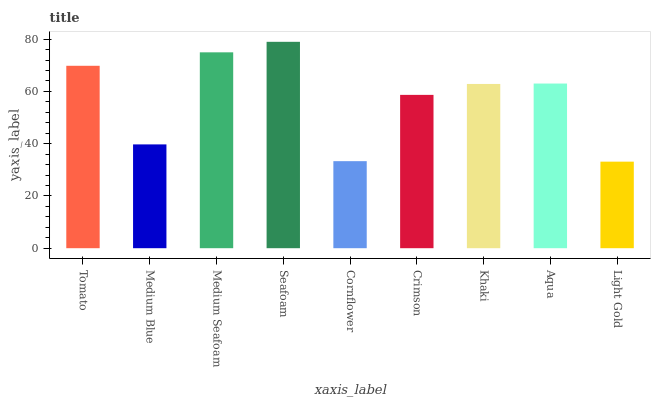Is Light Gold the minimum?
Answer yes or no. Yes. Is Seafoam the maximum?
Answer yes or no. Yes. Is Medium Blue the minimum?
Answer yes or no. No. Is Medium Blue the maximum?
Answer yes or no. No. Is Tomato greater than Medium Blue?
Answer yes or no. Yes. Is Medium Blue less than Tomato?
Answer yes or no. Yes. Is Medium Blue greater than Tomato?
Answer yes or no. No. Is Tomato less than Medium Blue?
Answer yes or no. No. Is Khaki the high median?
Answer yes or no. Yes. Is Khaki the low median?
Answer yes or no. Yes. Is Cornflower the high median?
Answer yes or no. No. Is Medium Seafoam the low median?
Answer yes or no. No. 